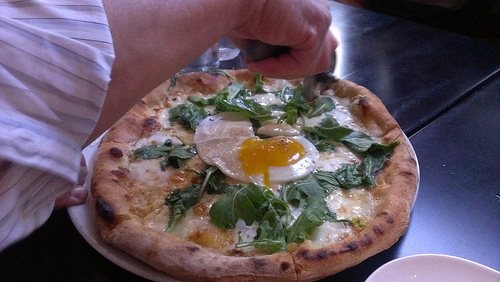What is the vegetable to the left of the cheese in this picture? The vegetable to the left of the cheese in the picture is spinach. 